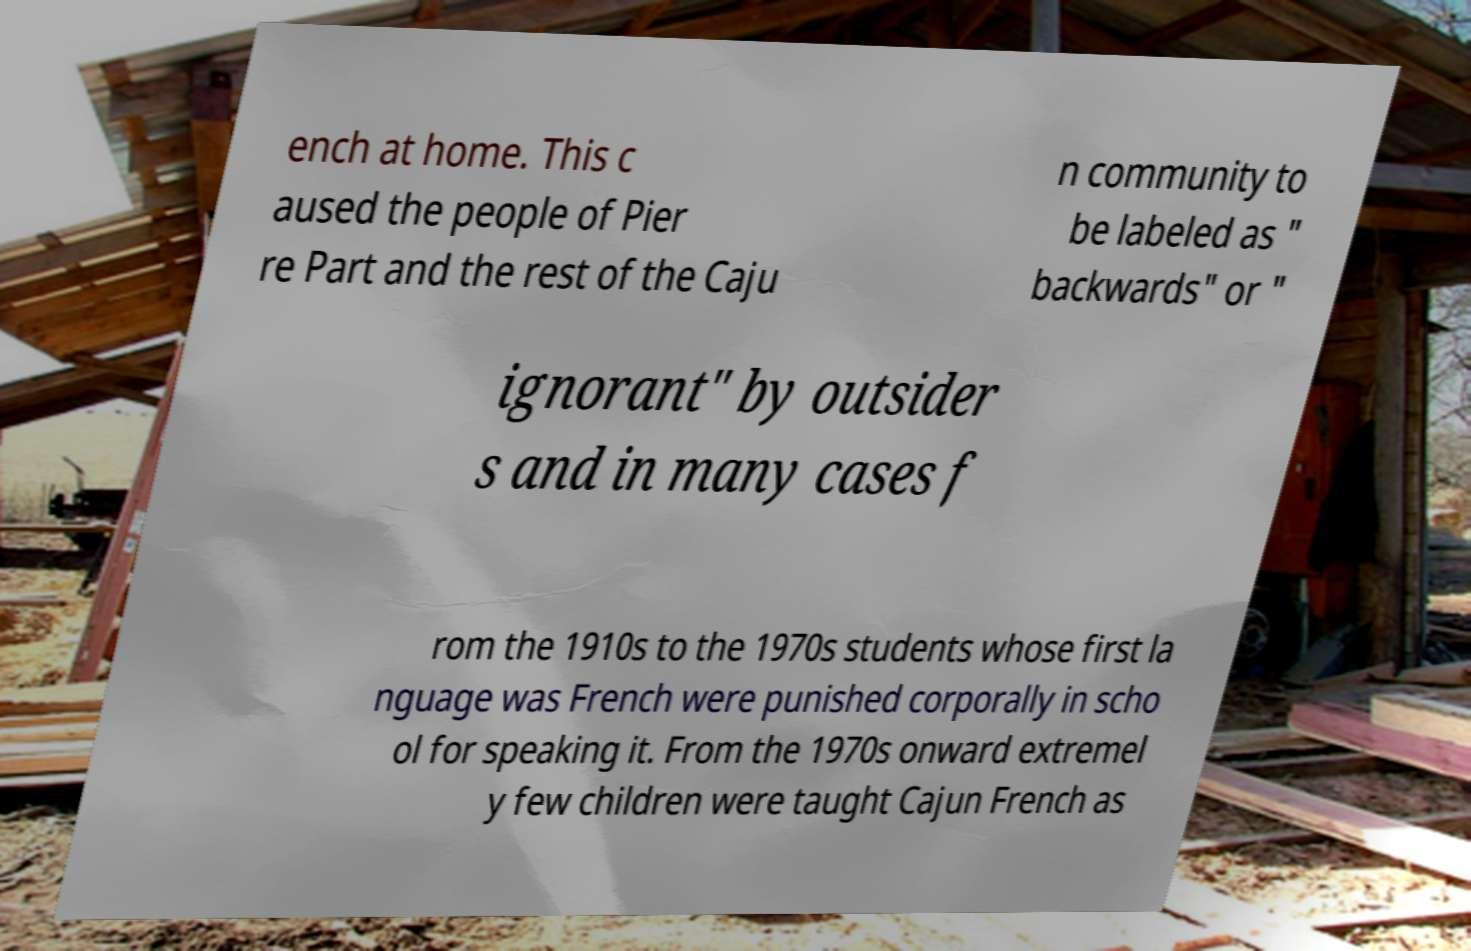Could you extract and type out the text from this image? ench at home. This c aused the people of Pier re Part and the rest of the Caju n community to be labeled as " backwards" or " ignorant" by outsider s and in many cases f rom the 1910s to the 1970s students whose first la nguage was French were punished corporally in scho ol for speaking it. From the 1970s onward extremel y few children were taught Cajun French as 